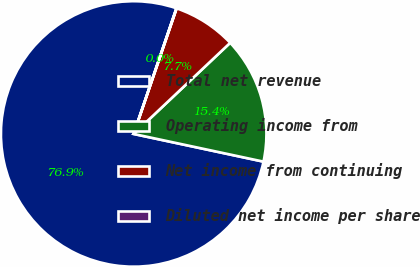<chart> <loc_0><loc_0><loc_500><loc_500><pie_chart><fcel>Total net revenue<fcel>Operating income from<fcel>Net income from continuing<fcel>Diluted net income per share<nl><fcel>76.87%<fcel>15.39%<fcel>7.71%<fcel>0.03%<nl></chart> 